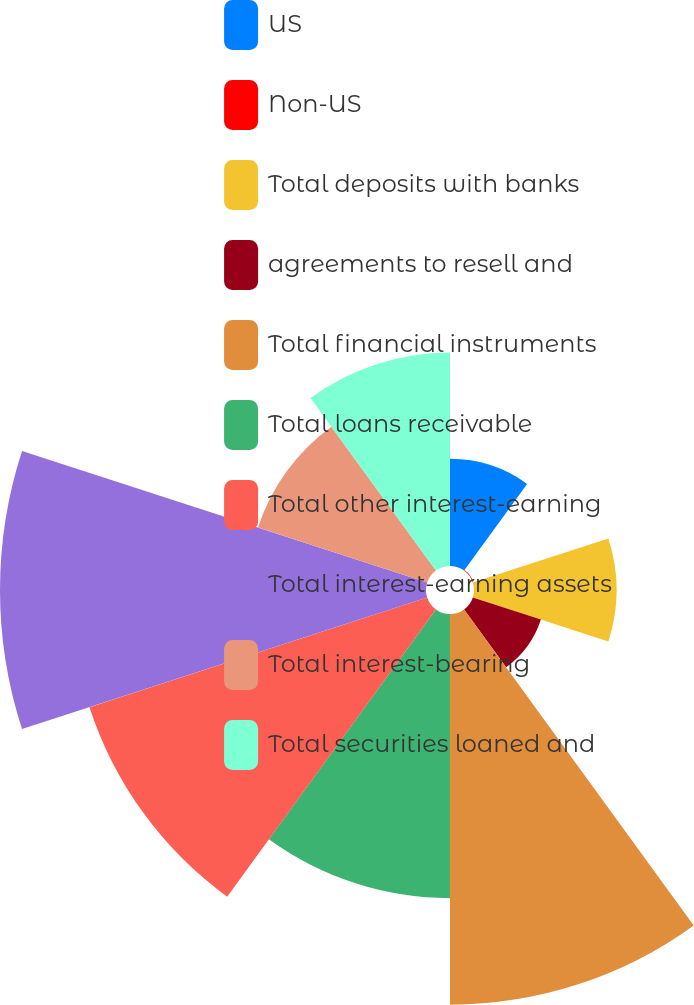Convert chart. <chart><loc_0><loc_0><loc_500><loc_500><pie_chart><fcel>US<fcel>Non-US<fcel>Total deposits with banks<fcel>agreements to resell and<fcel>Total financial instruments<fcel>Total loans receivable<fcel>Total other interest-earning<fcel>Total interest-earning assets<fcel>Total interest-bearing<fcel>Total securities loaned and<nl><fcel>4.94%<fcel>0.03%<fcel>6.57%<fcel>3.3%<fcel>18.01%<fcel>13.1%<fcel>16.37%<fcel>19.64%<fcel>8.2%<fcel>9.84%<nl></chart> 